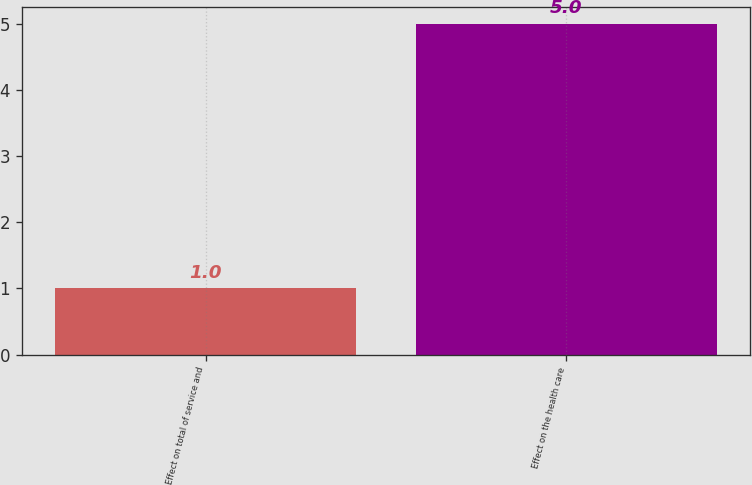<chart> <loc_0><loc_0><loc_500><loc_500><bar_chart><fcel>Effect on total of service and<fcel>Effect on the health care<nl><fcel>1<fcel>5<nl></chart> 